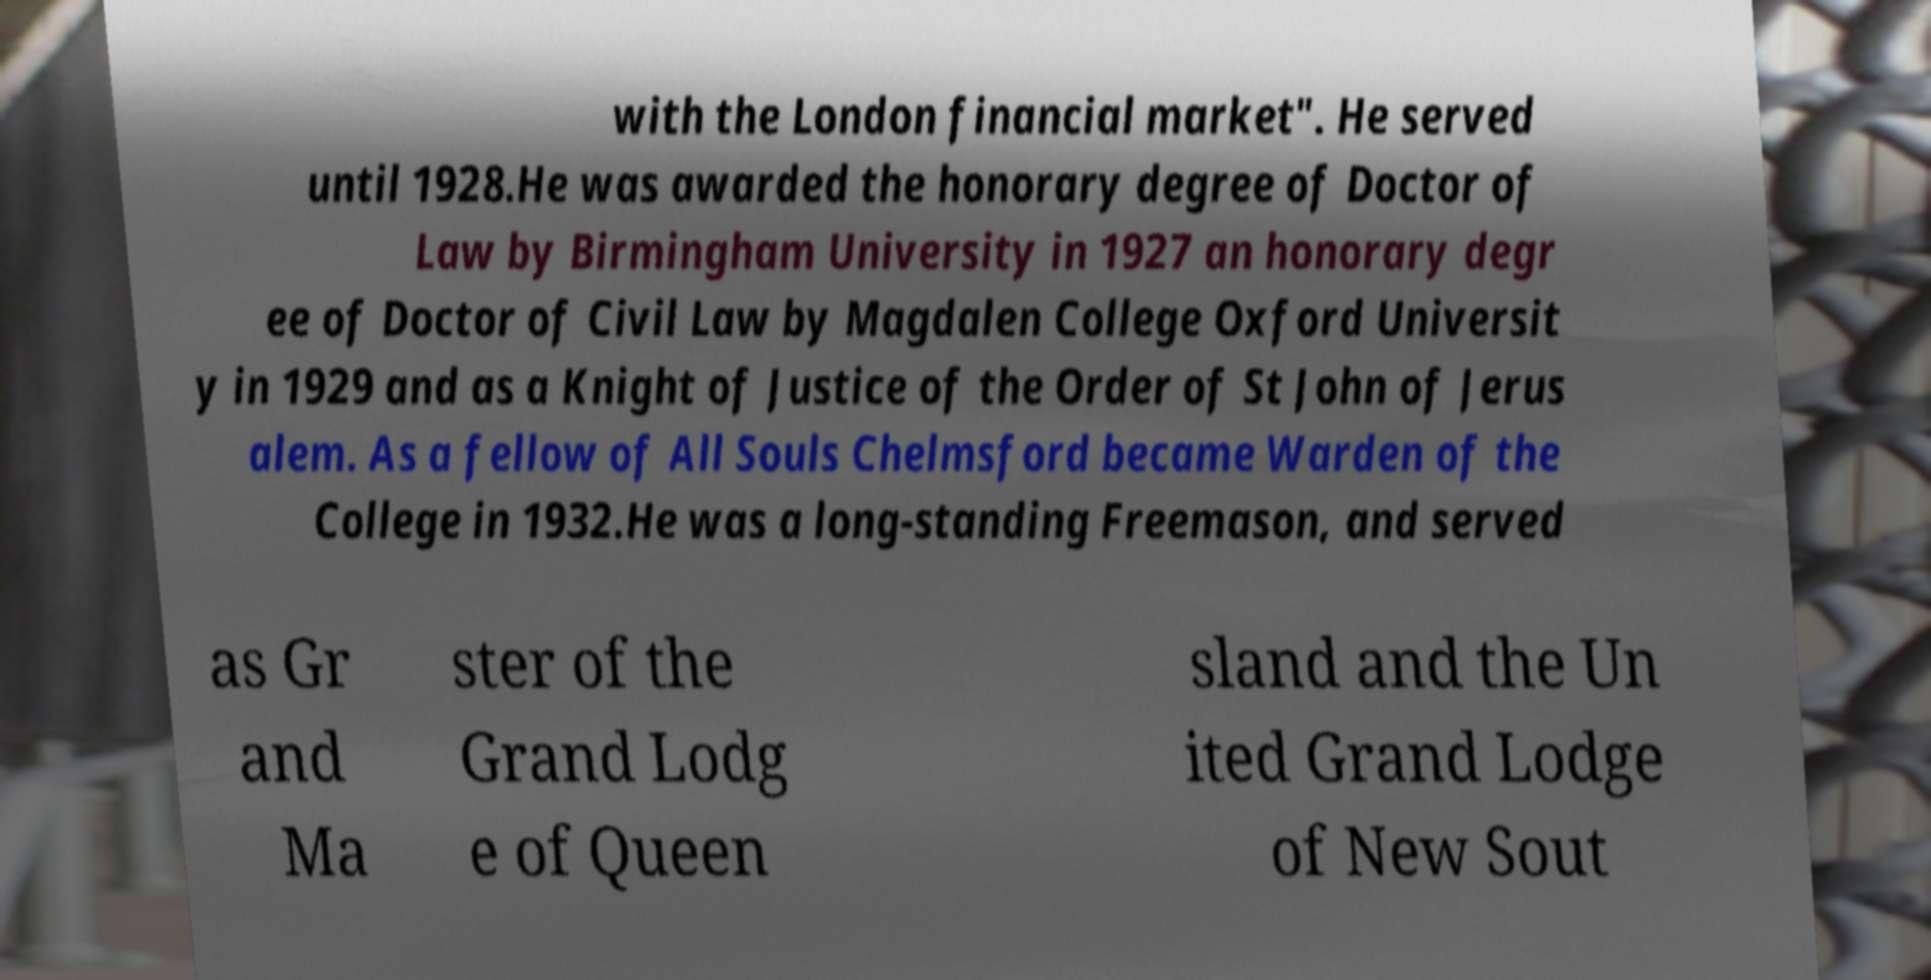Could you extract and type out the text from this image? with the London financial market". He served until 1928.He was awarded the honorary degree of Doctor of Law by Birmingham University in 1927 an honorary degr ee of Doctor of Civil Law by Magdalen College Oxford Universit y in 1929 and as a Knight of Justice of the Order of St John of Jerus alem. As a fellow of All Souls Chelmsford became Warden of the College in 1932.He was a long-standing Freemason, and served as Gr and Ma ster of the Grand Lodg e of Queen sland and the Un ited Grand Lodge of New Sout 